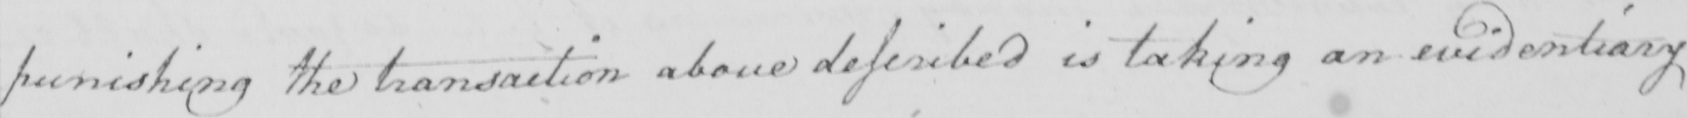Please transcribe the handwritten text in this image. punishing the transaction above described is taking an evidentiary 